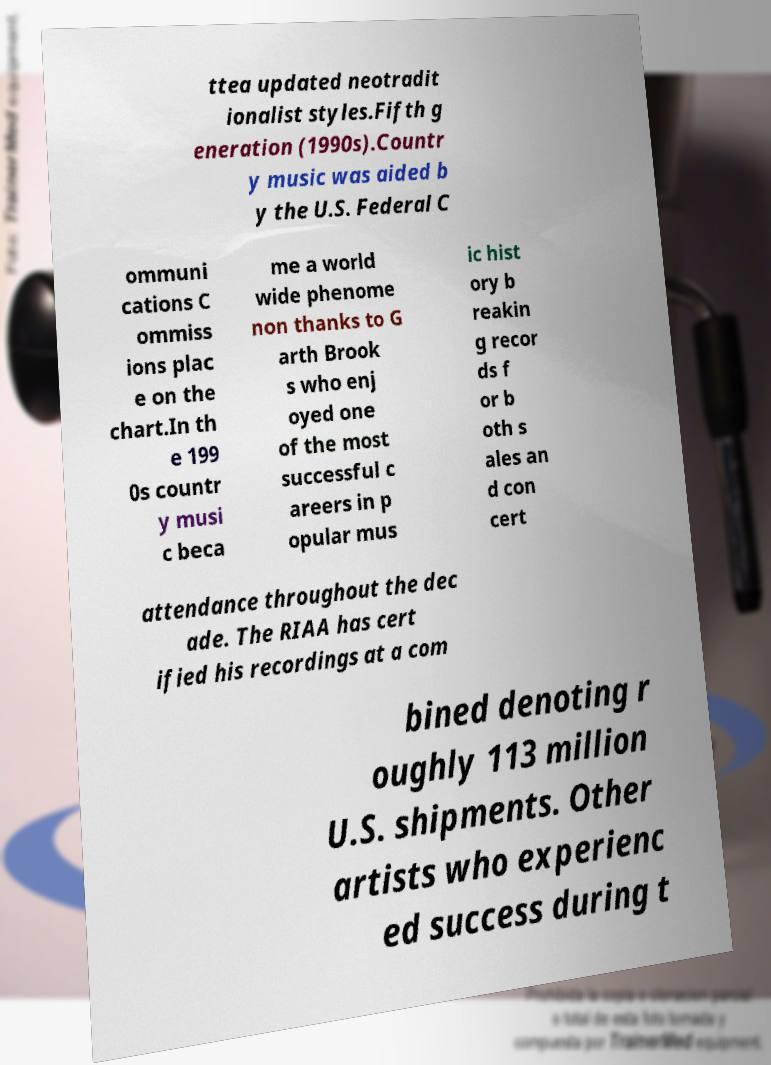Please read and relay the text visible in this image. What does it say? ttea updated neotradit ionalist styles.Fifth g eneration (1990s).Countr y music was aided b y the U.S. Federal C ommuni cations C ommiss ions plac e on the chart.In th e 199 0s countr y musi c beca me a world wide phenome non thanks to G arth Brook s who enj oyed one of the most successful c areers in p opular mus ic hist ory b reakin g recor ds f or b oth s ales an d con cert attendance throughout the dec ade. The RIAA has cert ified his recordings at a com bined denoting r oughly 113 million U.S. shipments. Other artists who experienc ed success during t 